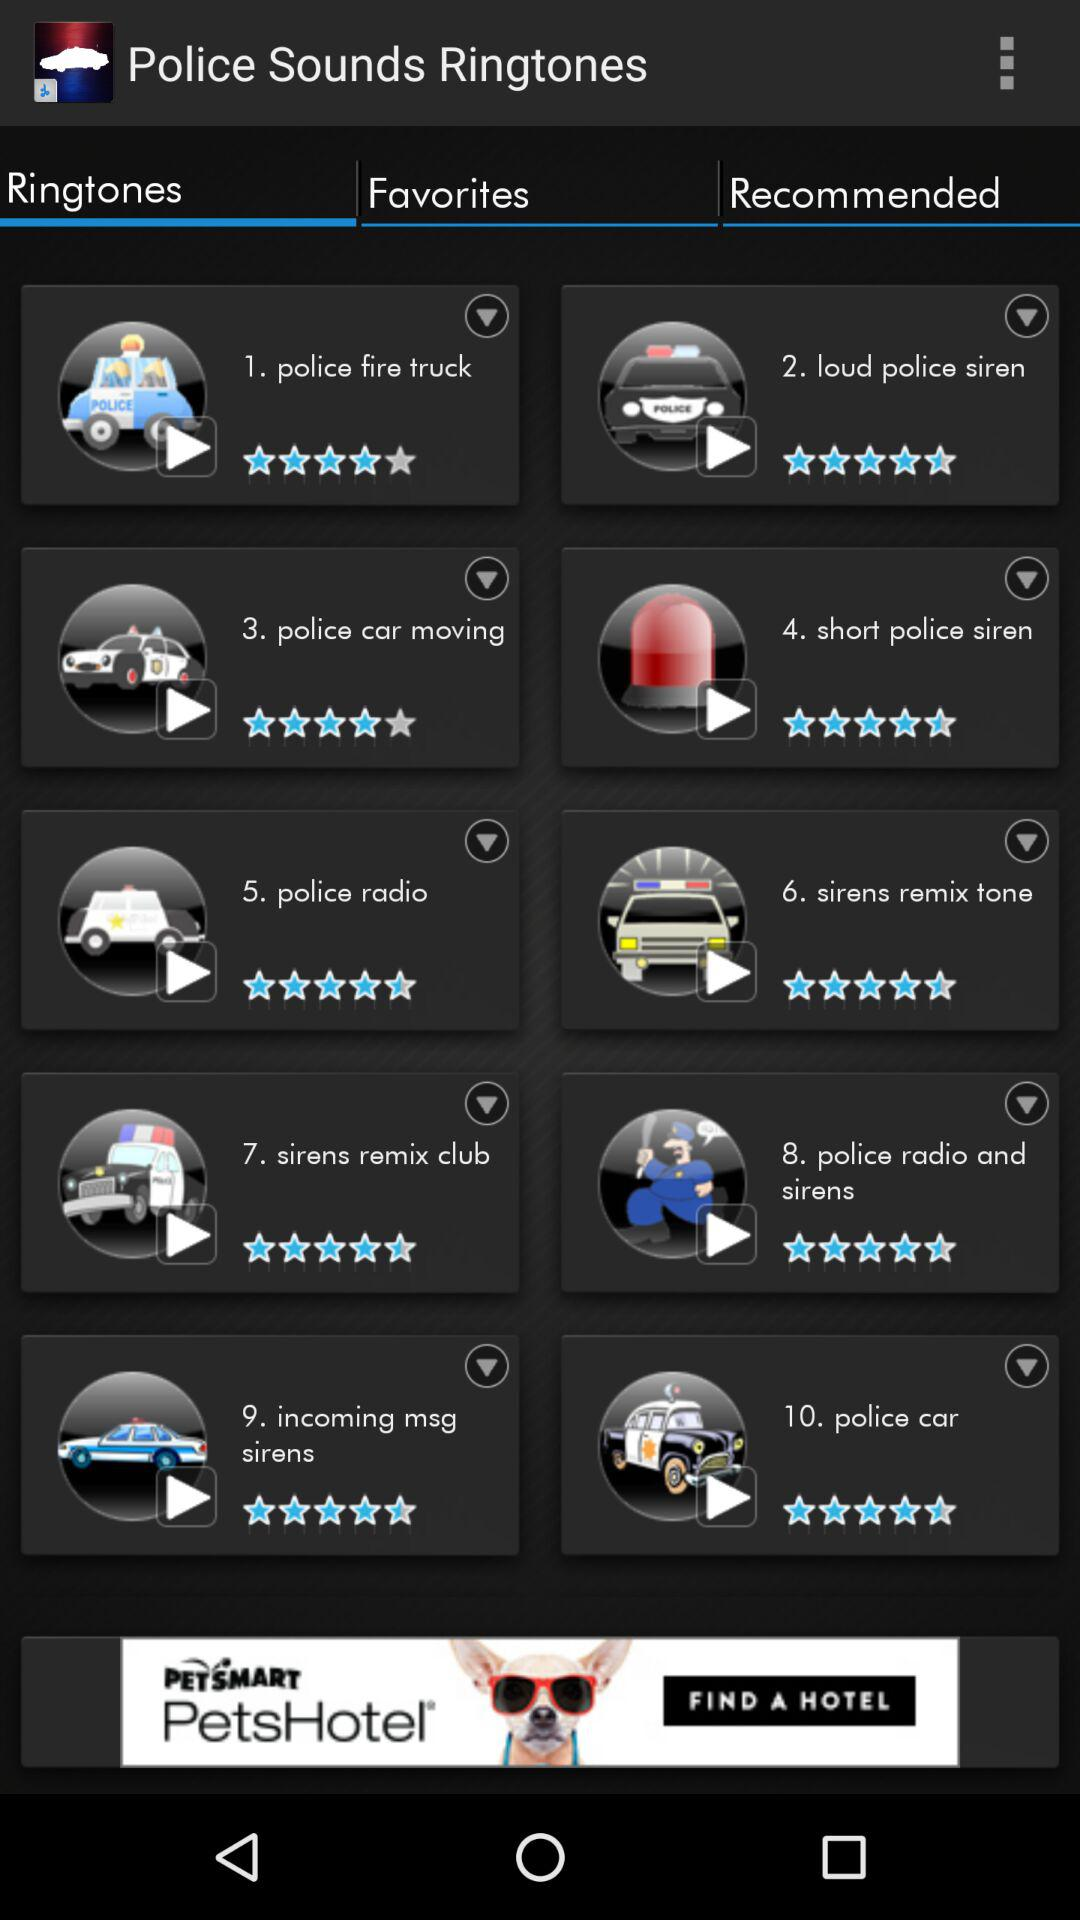What is the rating of the "police car moving" ringtone? The rating of the "police car moving" ringtone is 4 stars. 